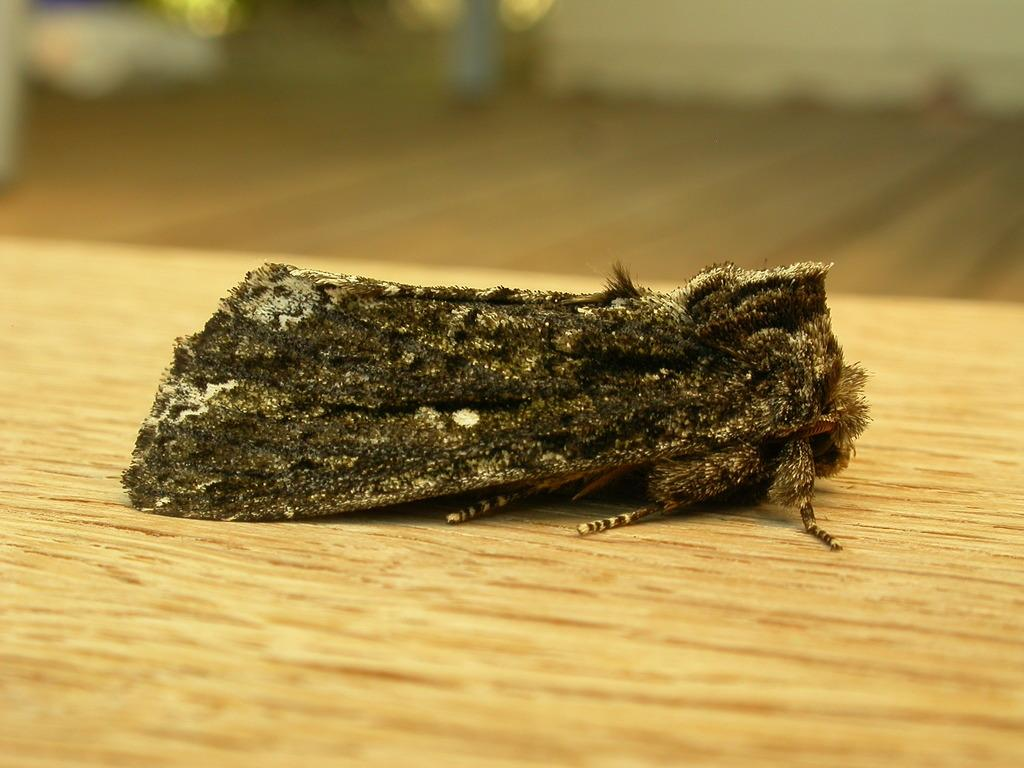What type of creature is present in the image? There is an insect in the image. Where is the insect located? The insect is on a wooden surface. Can you describe the background of the image? The background of the image is blurred. What type of haircut does the insect have in the image? Insects do not have hair, so it is not possible to determine the type of haircut the insect has in the image. Can you see the insect's face in the image? Insects do not have faces like humans, so it is not possible to see the insect's face in the image. 